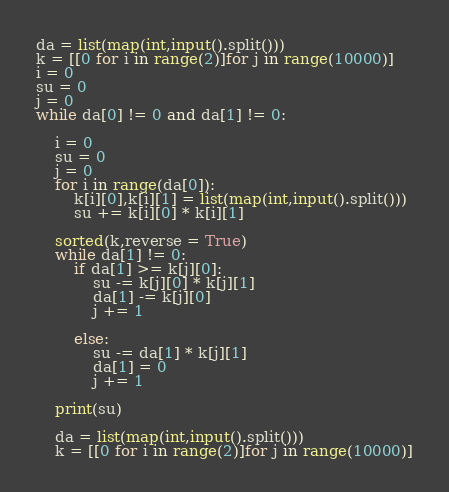Convert code to text. <code><loc_0><loc_0><loc_500><loc_500><_Python_>da = list(map(int,input().split()))
k = [[0 for i in range(2)]for j in range(10000)]
i = 0
su = 0
j = 0
while da[0] != 0 and da[1] != 0:

	i = 0
	su = 0
	j = 0
	for i in range(da[0]):
		k[i][0],k[i][1] = list(map(int,input().split()))
		su += k[i][0] * k[i][1]

	sorted(k,reverse = True)
	while da[1] != 0:
		if da[1] >= k[j][0]:
			su -= k[j][0] * k[j][1]
			da[1] -= k[j][0]
			j += 1

		else:
			su -= da[1] * k[j][1]
			da[1] = 0
			j += 1

	print(su)

	da = list(map(int,input().split()))
	k = [[0 for i in range(2)]for j in range(10000)]

</code> 